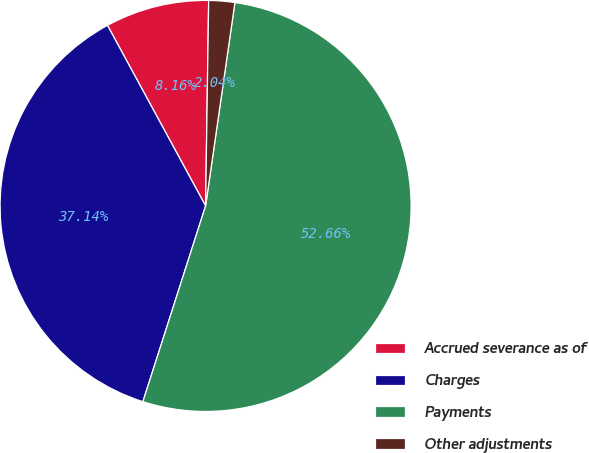Convert chart to OTSL. <chart><loc_0><loc_0><loc_500><loc_500><pie_chart><fcel>Accrued severance as of<fcel>Charges<fcel>Payments<fcel>Other adjustments<nl><fcel>8.16%<fcel>37.14%<fcel>52.65%<fcel>2.04%<nl></chart> 